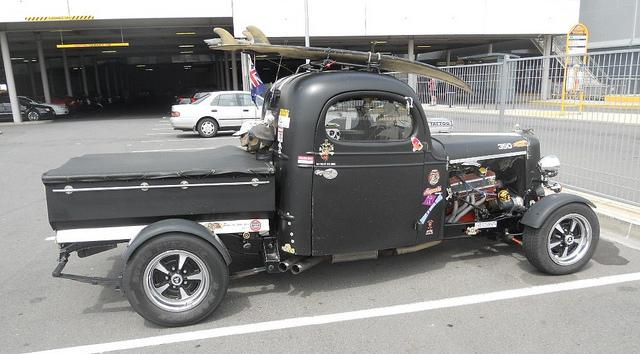What hobby does the car owner enjoy? surfing 